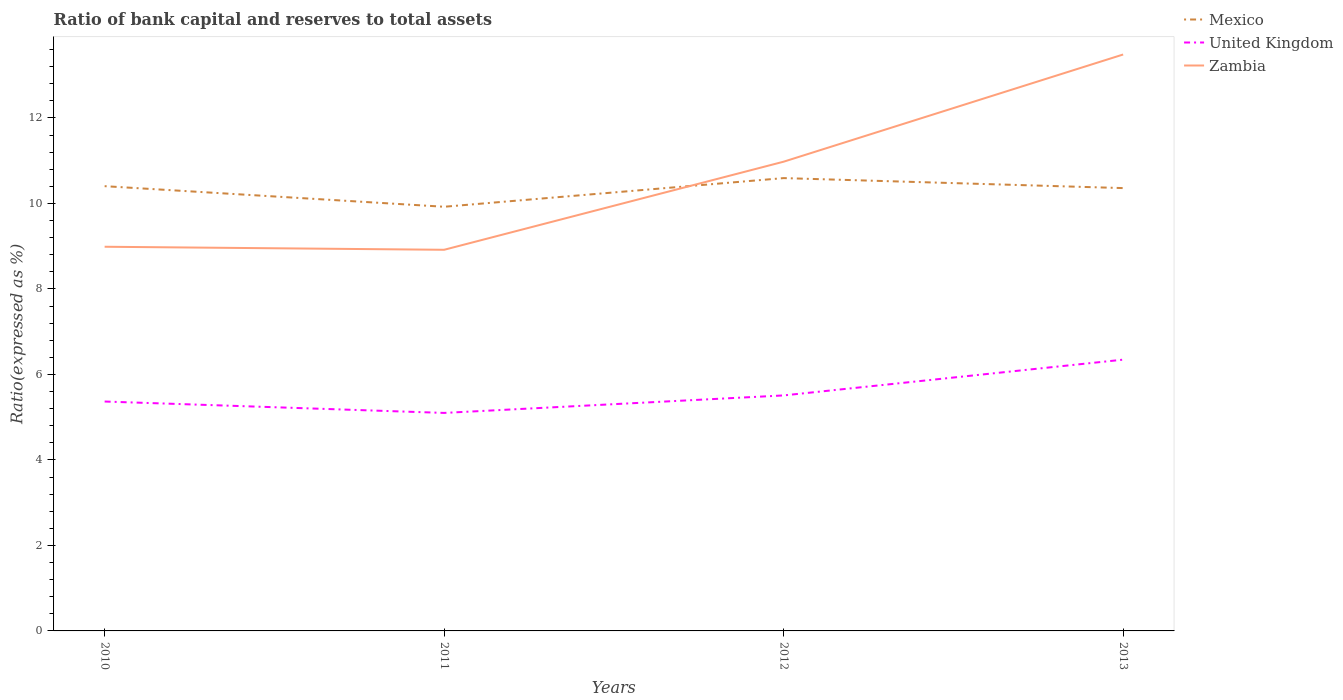How many different coloured lines are there?
Make the answer very short. 3. Across all years, what is the maximum ratio of bank capital and reserves to total assets in Zambia?
Provide a short and direct response. 8.92. In which year was the ratio of bank capital and reserves to total assets in Mexico maximum?
Make the answer very short. 2011. What is the total ratio of bank capital and reserves to total assets in United Kingdom in the graph?
Your answer should be compact. -0.14. What is the difference between the highest and the second highest ratio of bank capital and reserves to total assets in Mexico?
Your answer should be very brief. 0.67. What is the difference between the highest and the lowest ratio of bank capital and reserves to total assets in Zambia?
Keep it short and to the point. 2. Is the ratio of bank capital and reserves to total assets in United Kingdom strictly greater than the ratio of bank capital and reserves to total assets in Mexico over the years?
Give a very brief answer. Yes. How many lines are there?
Provide a short and direct response. 3. Does the graph contain any zero values?
Ensure brevity in your answer.  No. How are the legend labels stacked?
Provide a short and direct response. Vertical. What is the title of the graph?
Make the answer very short. Ratio of bank capital and reserves to total assets. Does "Iraq" appear as one of the legend labels in the graph?
Ensure brevity in your answer.  No. What is the label or title of the Y-axis?
Ensure brevity in your answer.  Ratio(expressed as %). What is the Ratio(expressed as %) in Mexico in 2010?
Provide a succinct answer. 10.4. What is the Ratio(expressed as %) of United Kingdom in 2010?
Offer a very short reply. 5.37. What is the Ratio(expressed as %) in Zambia in 2010?
Make the answer very short. 8.99. What is the Ratio(expressed as %) in Mexico in 2011?
Provide a succinct answer. 9.92. What is the Ratio(expressed as %) in United Kingdom in 2011?
Give a very brief answer. 5.1. What is the Ratio(expressed as %) in Zambia in 2011?
Provide a short and direct response. 8.92. What is the Ratio(expressed as %) of Mexico in 2012?
Offer a terse response. 10.59. What is the Ratio(expressed as %) in United Kingdom in 2012?
Offer a very short reply. 5.51. What is the Ratio(expressed as %) in Zambia in 2012?
Offer a terse response. 10.98. What is the Ratio(expressed as %) of Mexico in 2013?
Ensure brevity in your answer.  10.36. What is the Ratio(expressed as %) of United Kingdom in 2013?
Your answer should be compact. 6.35. What is the Ratio(expressed as %) of Zambia in 2013?
Your answer should be compact. 13.48. Across all years, what is the maximum Ratio(expressed as %) of Mexico?
Make the answer very short. 10.59. Across all years, what is the maximum Ratio(expressed as %) in United Kingdom?
Ensure brevity in your answer.  6.35. Across all years, what is the maximum Ratio(expressed as %) in Zambia?
Provide a short and direct response. 13.48. Across all years, what is the minimum Ratio(expressed as %) in Mexico?
Provide a succinct answer. 9.92. Across all years, what is the minimum Ratio(expressed as %) of United Kingdom?
Offer a terse response. 5.1. Across all years, what is the minimum Ratio(expressed as %) of Zambia?
Ensure brevity in your answer.  8.92. What is the total Ratio(expressed as %) of Mexico in the graph?
Keep it short and to the point. 41.28. What is the total Ratio(expressed as %) in United Kingdom in the graph?
Ensure brevity in your answer.  22.32. What is the total Ratio(expressed as %) of Zambia in the graph?
Your response must be concise. 42.36. What is the difference between the Ratio(expressed as %) in Mexico in 2010 and that in 2011?
Ensure brevity in your answer.  0.48. What is the difference between the Ratio(expressed as %) of United Kingdom in 2010 and that in 2011?
Provide a short and direct response. 0.27. What is the difference between the Ratio(expressed as %) in Zambia in 2010 and that in 2011?
Provide a succinct answer. 0.07. What is the difference between the Ratio(expressed as %) in Mexico in 2010 and that in 2012?
Your answer should be compact. -0.19. What is the difference between the Ratio(expressed as %) of United Kingdom in 2010 and that in 2012?
Your response must be concise. -0.14. What is the difference between the Ratio(expressed as %) in Zambia in 2010 and that in 2012?
Ensure brevity in your answer.  -1.99. What is the difference between the Ratio(expressed as %) in Mexico in 2010 and that in 2013?
Your answer should be very brief. 0.05. What is the difference between the Ratio(expressed as %) of United Kingdom in 2010 and that in 2013?
Provide a succinct answer. -0.98. What is the difference between the Ratio(expressed as %) of Zambia in 2010 and that in 2013?
Offer a terse response. -4.5. What is the difference between the Ratio(expressed as %) in Mexico in 2011 and that in 2012?
Provide a short and direct response. -0.67. What is the difference between the Ratio(expressed as %) of United Kingdom in 2011 and that in 2012?
Make the answer very short. -0.41. What is the difference between the Ratio(expressed as %) in Zambia in 2011 and that in 2012?
Offer a very short reply. -2.06. What is the difference between the Ratio(expressed as %) in Mexico in 2011 and that in 2013?
Your response must be concise. -0.44. What is the difference between the Ratio(expressed as %) in United Kingdom in 2011 and that in 2013?
Make the answer very short. -1.25. What is the difference between the Ratio(expressed as %) of Zambia in 2011 and that in 2013?
Ensure brevity in your answer.  -4.57. What is the difference between the Ratio(expressed as %) of Mexico in 2012 and that in 2013?
Provide a succinct answer. 0.23. What is the difference between the Ratio(expressed as %) of United Kingdom in 2012 and that in 2013?
Your response must be concise. -0.84. What is the difference between the Ratio(expressed as %) in Zambia in 2012 and that in 2013?
Your response must be concise. -2.51. What is the difference between the Ratio(expressed as %) of Mexico in 2010 and the Ratio(expressed as %) of United Kingdom in 2011?
Your response must be concise. 5.3. What is the difference between the Ratio(expressed as %) of Mexico in 2010 and the Ratio(expressed as %) of Zambia in 2011?
Ensure brevity in your answer.  1.49. What is the difference between the Ratio(expressed as %) of United Kingdom in 2010 and the Ratio(expressed as %) of Zambia in 2011?
Ensure brevity in your answer.  -3.55. What is the difference between the Ratio(expressed as %) in Mexico in 2010 and the Ratio(expressed as %) in United Kingdom in 2012?
Give a very brief answer. 4.89. What is the difference between the Ratio(expressed as %) of Mexico in 2010 and the Ratio(expressed as %) of Zambia in 2012?
Provide a short and direct response. -0.57. What is the difference between the Ratio(expressed as %) of United Kingdom in 2010 and the Ratio(expressed as %) of Zambia in 2012?
Make the answer very short. -5.61. What is the difference between the Ratio(expressed as %) of Mexico in 2010 and the Ratio(expressed as %) of United Kingdom in 2013?
Make the answer very short. 4.06. What is the difference between the Ratio(expressed as %) in Mexico in 2010 and the Ratio(expressed as %) in Zambia in 2013?
Provide a succinct answer. -3.08. What is the difference between the Ratio(expressed as %) of United Kingdom in 2010 and the Ratio(expressed as %) of Zambia in 2013?
Provide a succinct answer. -8.12. What is the difference between the Ratio(expressed as %) in Mexico in 2011 and the Ratio(expressed as %) in United Kingdom in 2012?
Offer a terse response. 4.41. What is the difference between the Ratio(expressed as %) of Mexico in 2011 and the Ratio(expressed as %) of Zambia in 2012?
Your response must be concise. -1.05. What is the difference between the Ratio(expressed as %) of United Kingdom in 2011 and the Ratio(expressed as %) of Zambia in 2012?
Provide a short and direct response. -5.88. What is the difference between the Ratio(expressed as %) of Mexico in 2011 and the Ratio(expressed as %) of United Kingdom in 2013?
Your response must be concise. 3.58. What is the difference between the Ratio(expressed as %) of Mexico in 2011 and the Ratio(expressed as %) of Zambia in 2013?
Give a very brief answer. -3.56. What is the difference between the Ratio(expressed as %) in United Kingdom in 2011 and the Ratio(expressed as %) in Zambia in 2013?
Keep it short and to the point. -8.38. What is the difference between the Ratio(expressed as %) in Mexico in 2012 and the Ratio(expressed as %) in United Kingdom in 2013?
Offer a terse response. 4.25. What is the difference between the Ratio(expressed as %) in Mexico in 2012 and the Ratio(expressed as %) in Zambia in 2013?
Ensure brevity in your answer.  -2.89. What is the difference between the Ratio(expressed as %) in United Kingdom in 2012 and the Ratio(expressed as %) in Zambia in 2013?
Your answer should be very brief. -7.97. What is the average Ratio(expressed as %) in Mexico per year?
Ensure brevity in your answer.  10.32. What is the average Ratio(expressed as %) in United Kingdom per year?
Your answer should be compact. 5.58. What is the average Ratio(expressed as %) of Zambia per year?
Provide a succinct answer. 10.59. In the year 2010, what is the difference between the Ratio(expressed as %) of Mexico and Ratio(expressed as %) of United Kingdom?
Your answer should be compact. 5.04. In the year 2010, what is the difference between the Ratio(expressed as %) in Mexico and Ratio(expressed as %) in Zambia?
Give a very brief answer. 1.42. In the year 2010, what is the difference between the Ratio(expressed as %) of United Kingdom and Ratio(expressed as %) of Zambia?
Give a very brief answer. -3.62. In the year 2011, what is the difference between the Ratio(expressed as %) of Mexico and Ratio(expressed as %) of United Kingdom?
Ensure brevity in your answer.  4.82. In the year 2011, what is the difference between the Ratio(expressed as %) in United Kingdom and Ratio(expressed as %) in Zambia?
Make the answer very short. -3.82. In the year 2012, what is the difference between the Ratio(expressed as %) in Mexico and Ratio(expressed as %) in United Kingdom?
Make the answer very short. 5.08. In the year 2012, what is the difference between the Ratio(expressed as %) in Mexico and Ratio(expressed as %) in Zambia?
Offer a very short reply. -0.38. In the year 2012, what is the difference between the Ratio(expressed as %) in United Kingdom and Ratio(expressed as %) in Zambia?
Make the answer very short. -5.47. In the year 2013, what is the difference between the Ratio(expressed as %) in Mexico and Ratio(expressed as %) in United Kingdom?
Provide a short and direct response. 4.01. In the year 2013, what is the difference between the Ratio(expressed as %) of Mexico and Ratio(expressed as %) of Zambia?
Ensure brevity in your answer.  -3.13. In the year 2013, what is the difference between the Ratio(expressed as %) of United Kingdom and Ratio(expressed as %) of Zambia?
Give a very brief answer. -7.14. What is the ratio of the Ratio(expressed as %) of Mexico in 2010 to that in 2011?
Keep it short and to the point. 1.05. What is the ratio of the Ratio(expressed as %) of United Kingdom in 2010 to that in 2011?
Offer a very short reply. 1.05. What is the ratio of the Ratio(expressed as %) in Mexico in 2010 to that in 2012?
Give a very brief answer. 0.98. What is the ratio of the Ratio(expressed as %) in United Kingdom in 2010 to that in 2012?
Offer a very short reply. 0.97. What is the ratio of the Ratio(expressed as %) of Zambia in 2010 to that in 2012?
Provide a succinct answer. 0.82. What is the ratio of the Ratio(expressed as %) in United Kingdom in 2010 to that in 2013?
Your response must be concise. 0.85. What is the ratio of the Ratio(expressed as %) of Zambia in 2010 to that in 2013?
Give a very brief answer. 0.67. What is the ratio of the Ratio(expressed as %) in Mexico in 2011 to that in 2012?
Your answer should be very brief. 0.94. What is the ratio of the Ratio(expressed as %) of United Kingdom in 2011 to that in 2012?
Offer a very short reply. 0.93. What is the ratio of the Ratio(expressed as %) in Zambia in 2011 to that in 2012?
Keep it short and to the point. 0.81. What is the ratio of the Ratio(expressed as %) of Mexico in 2011 to that in 2013?
Ensure brevity in your answer.  0.96. What is the ratio of the Ratio(expressed as %) of United Kingdom in 2011 to that in 2013?
Offer a terse response. 0.8. What is the ratio of the Ratio(expressed as %) of Zambia in 2011 to that in 2013?
Keep it short and to the point. 0.66. What is the ratio of the Ratio(expressed as %) of Mexico in 2012 to that in 2013?
Keep it short and to the point. 1.02. What is the ratio of the Ratio(expressed as %) in United Kingdom in 2012 to that in 2013?
Ensure brevity in your answer.  0.87. What is the ratio of the Ratio(expressed as %) of Zambia in 2012 to that in 2013?
Keep it short and to the point. 0.81. What is the difference between the highest and the second highest Ratio(expressed as %) of Mexico?
Your answer should be very brief. 0.19. What is the difference between the highest and the second highest Ratio(expressed as %) in United Kingdom?
Ensure brevity in your answer.  0.84. What is the difference between the highest and the second highest Ratio(expressed as %) of Zambia?
Make the answer very short. 2.51. What is the difference between the highest and the lowest Ratio(expressed as %) in Mexico?
Make the answer very short. 0.67. What is the difference between the highest and the lowest Ratio(expressed as %) of United Kingdom?
Your answer should be compact. 1.25. What is the difference between the highest and the lowest Ratio(expressed as %) of Zambia?
Your response must be concise. 4.57. 